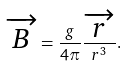<formula> <loc_0><loc_0><loc_500><loc_500>\overrightarrow { B } = \frac { g } { 4 \pi } \frac { \overrightarrow { r } } { r ^ { 3 } } .</formula> 